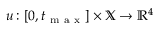<formula> <loc_0><loc_0><loc_500><loc_500>{ u \colon [ 0 , t _ { m a x } ] \times \mathbb { X } \to \mathbb { R } ^ { 4 } }</formula> 